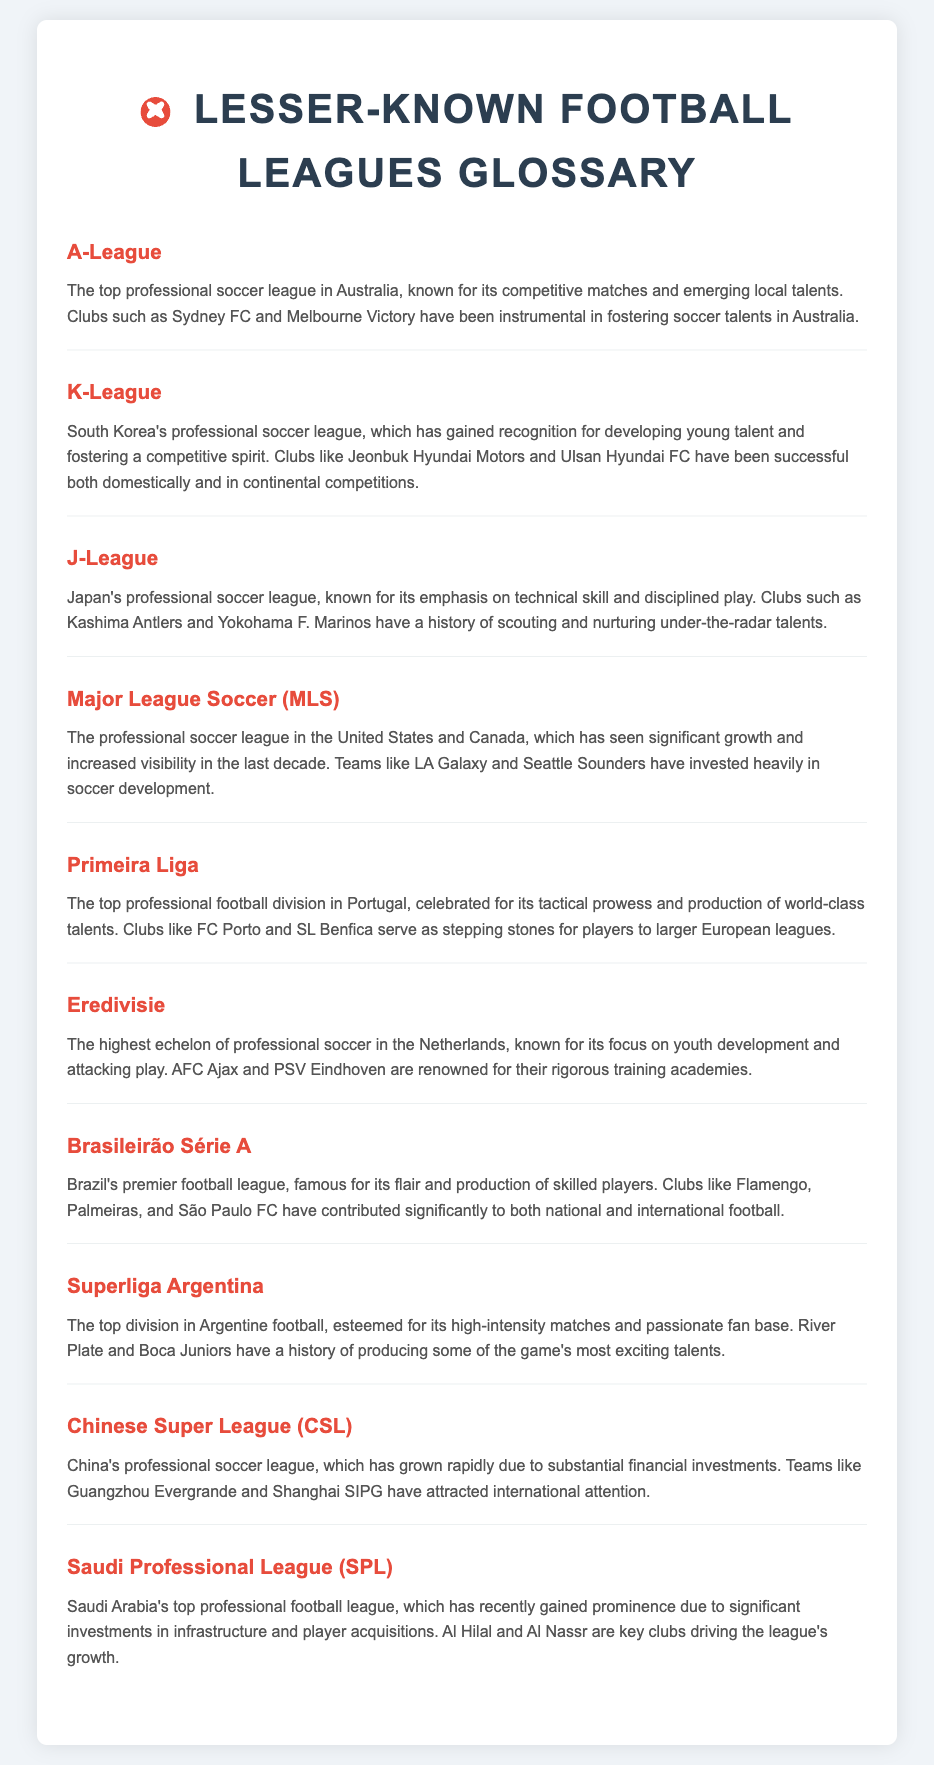What is the top professional soccer league in Australia? The document states that the A-League is the top professional soccer league in Australia, known for its competitive matches and emerging local talents.
Answer: A-League Which country’s league is known for its emphasis on technical skill? The J-League is recognized in the document for its emphasis on technical skill and disciplined play in Japan.
Answer: Japan What are the key clubs in the Brazilian league according to the document? The document lists Flamengo, Palmeiras, and São Paulo FC as key clubs in the Brasileirão Série A.
Answer: Flamengo, Palmeiras, São Paulo FC Which league has clubs that serve as stepping stones to larger European leagues? The Primeira Liga in Portugal is highlighted in the document for producing world-class talents and serving as stepping stones to larger European leagues.
Answer: Primeira Liga Which league has gained prominence due to significant investments in player acquisitions? The Saudi Professional League (SPL) has gained prominence due to substantial investments, as noted in the document.
Answer: Saudi Professional League (SPL) What is the professional league in the United States and Canada? The document identifies Major League Soccer (MLS) as the professional league in the United States and Canada.
Answer: Major League Soccer (MLS) Which league is described as having a passionate fan base? The Superliga Argentina is described as having a high-intensity matches and a passionate fan base in the document.
Answer: Superliga Argentina 